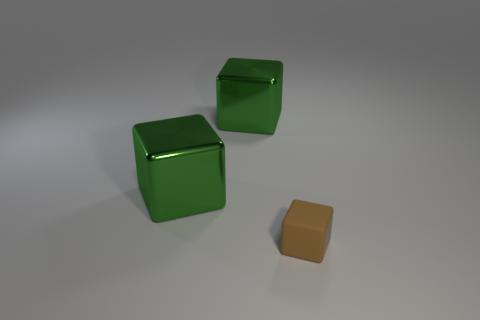Is there any other thing that has the same material as the tiny brown cube?
Your response must be concise. No. What number of big things are either matte objects or cubes?
Give a very brief answer. 2. How many things are either green blocks or blocks behind the small rubber object?
Give a very brief answer. 2. What shape is the rubber object?
Provide a succinct answer. Cube. How many green things are large things or rubber objects?
Make the answer very short. 2. Is the number of small matte things greater than the number of things?
Provide a short and direct response. No. Are there any other things of the same shape as the tiny brown thing?
Your answer should be compact. Yes. Is the number of large green blocks that are to the left of the brown matte thing greater than the number of large brown metal cylinders?
Offer a terse response. Yes. How many metallic things are either big objects or blocks?
Your response must be concise. 2. How many green metallic cubes are to the left of the tiny matte object?
Give a very brief answer. 2. 